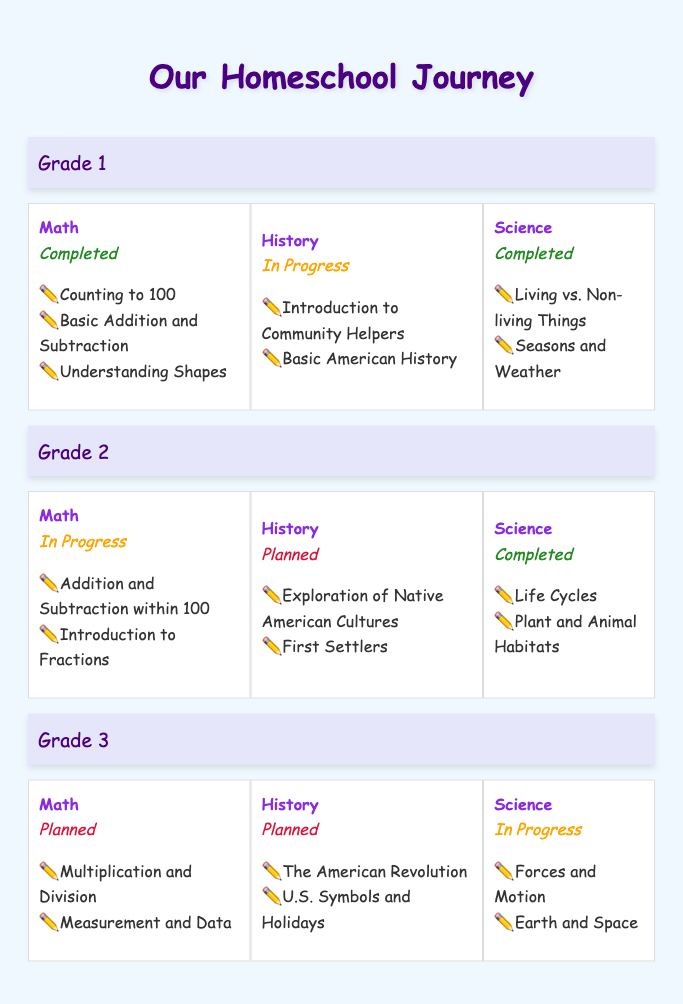What is the progress status of Math for Grade 1? The table indicates that the status for Math in Grade 1 is "Completed."
Answer: Completed What topics are covered in Science for Grade 2? The table lists two topics under Science for Grade 2: "Life Cycles" and "Plant and Animal Habitats."
Answer: Life Cycles, Plant and Animal Habitats How many subjects are listed for Grade 3? In the table, there are three subjects listed for Grade 3: Math, History, and Science.
Answer: 3 Is History for Grade 2 completed? The table indicates that the progress for History in Grade 2 is "Planned," meaning it is not completed.
Answer: No Which grade has all subjects completed? By examining the table, Grade 1 has both Math and Science completed, while History is in progress. Grade 2 has Science completed, while History is planned. Thus, Grade 1 is the only one where the majority of subjects are completed.
Answer: Grade 1 What are the total number of topics covered in Math across all grades? For Grade 1, there are 3 topics; for Grade 2, there are 2 topics; for Grade 3, there are 2 topics. Summing these gives 3 + 2 + 2 = 7 topics covered in Math across all grades.
Answer: 7 What is the combined progress of Science and History for Grade 1? For Grade 1, Science is "Completed," and History is "In Progress." Since both subjects are not at the same status, the combined progress can be characterized as having one completed and one in progress.
Answer: One completed and one in progress How many subjects have the progress status of "Planned"? The table shows two subjects with the progress status of "Planned": History for Grade 2 and both Math and History for Grade 3. Thus, there are three subjects in total that are planned.
Answer: 3 What is the average progress status of Math across all grades? To determine the average, we observe that for Grade 1 it is "Completed," Grade 2 is "In Progress," and Grade 3 is "Planned." Since these are qualitative statuses, rather than numerical, we conclude that on average, the status leans towards being planned.
Answer: Planned 